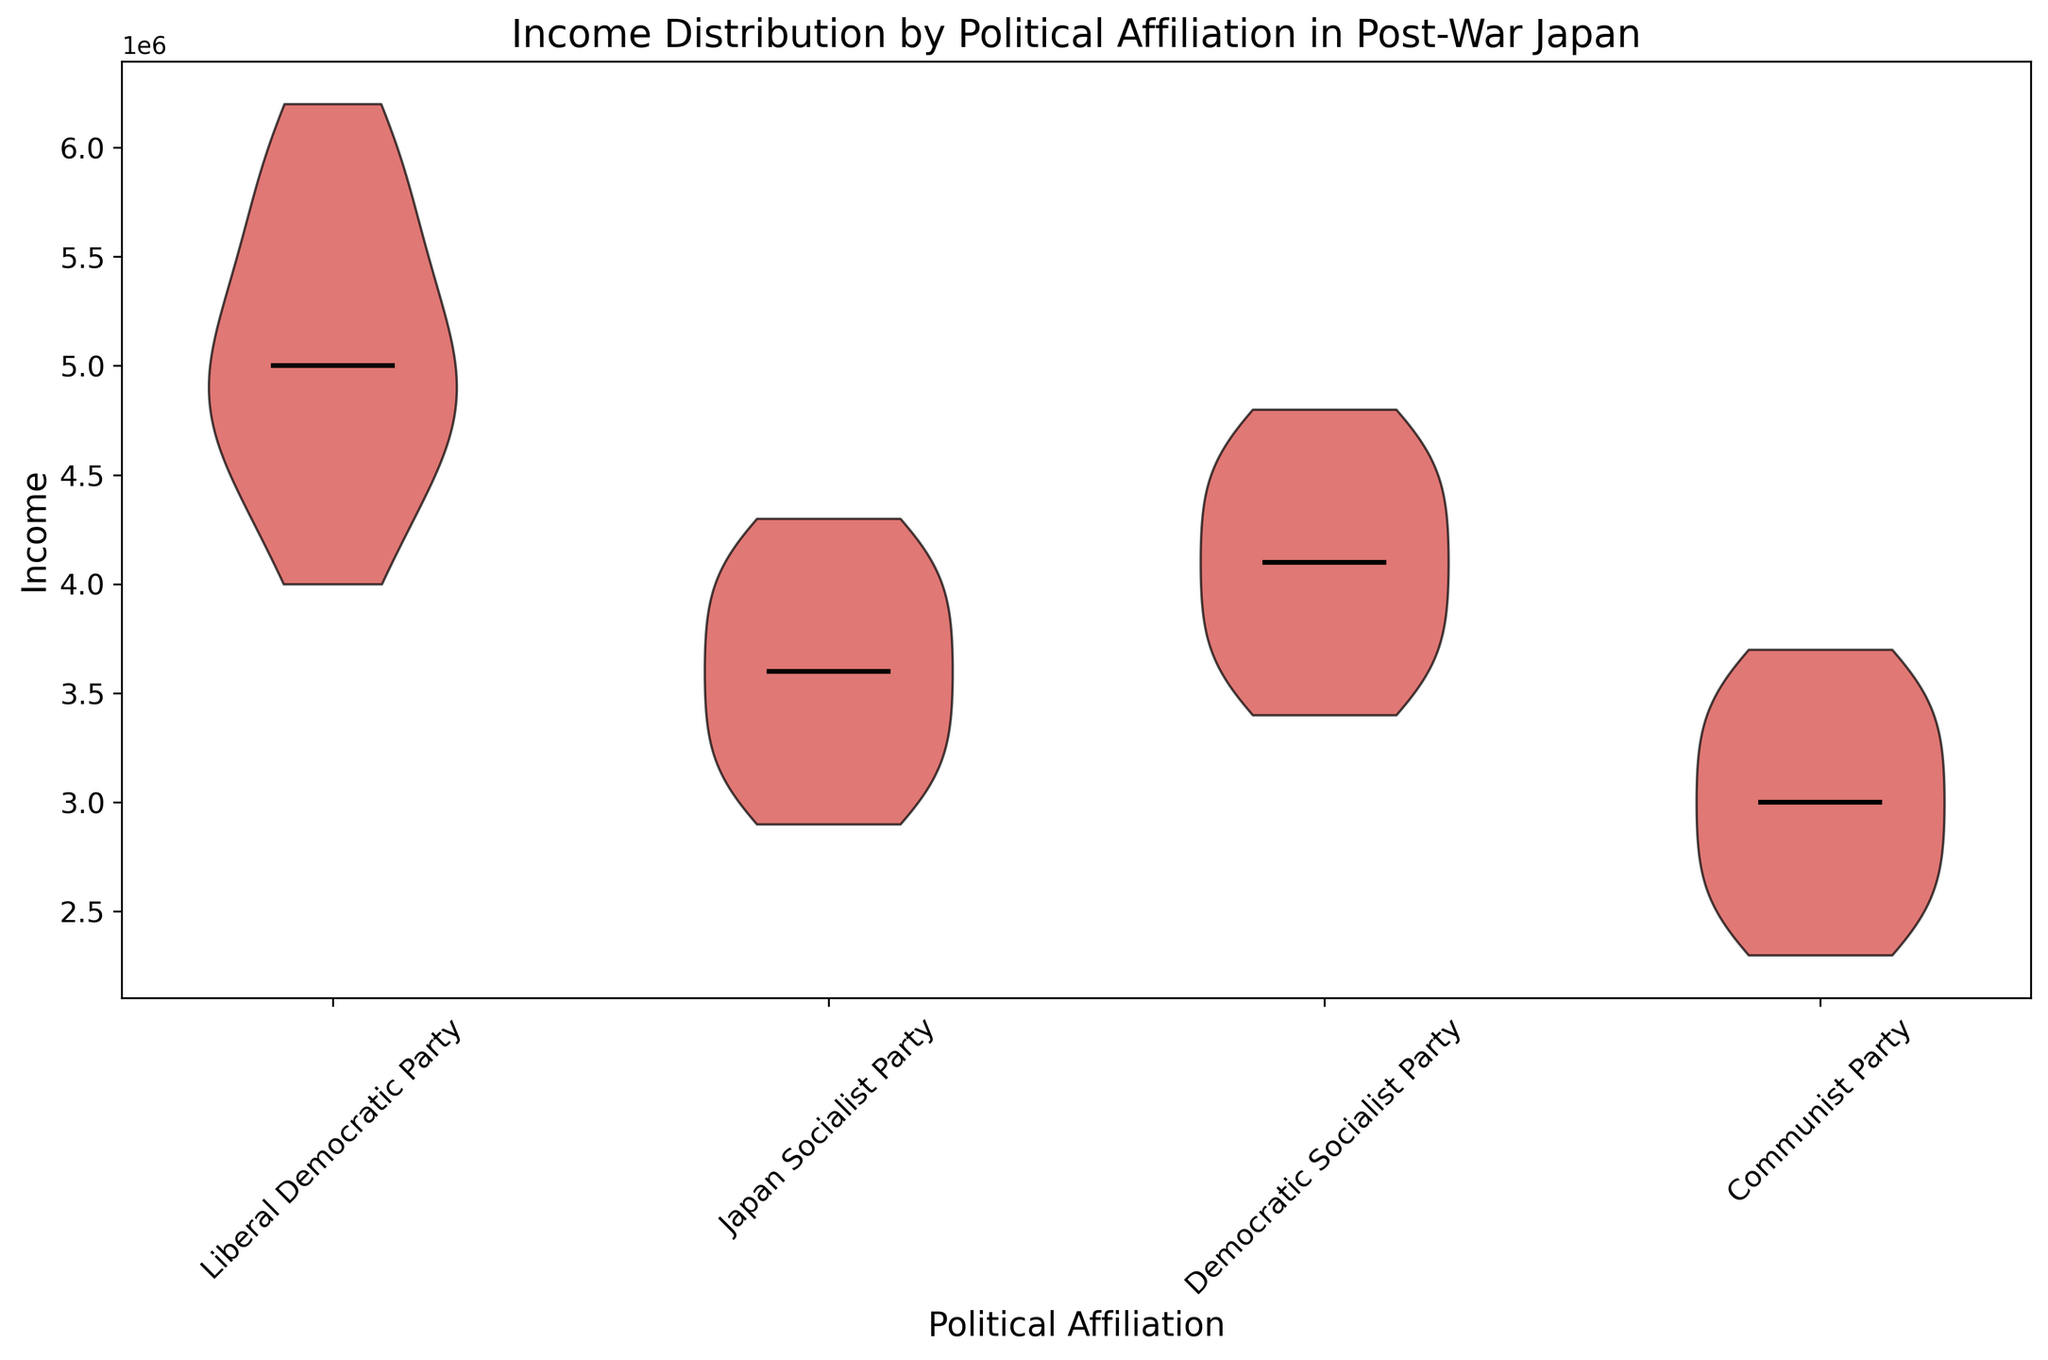What is the median income for each political affiliation? Look at the horizontal lines within each violin shape, which represent the median incomes for each political affiliation. The corresponding y-values of these lines indicate the median income.
Answer: Liberal Democratic Party: 5300000, Japan Socialist Party: 3600000, Democratic Socialist Party: 4200000, Communist Party: 2900000 Which political affiliation has the highest median income? Compare the median incomes represented by the horizontal lines within each violin plot to determine which one is the highest.
Answer: Liberal Democratic Party Is the median income of the Japan Socialist Party greater than that of the Communist Party? Compare the horizontal lines representing the median incomes for the Japan Socialist Party and the Communist Party to see which one is higher.
Answer: Yes How do the income distributions of the Liberal Democratic Party and the Japan Socialist Party differ visually? Observe the shapes and spreads of the violin plots for both parties. The Liberal Democratic Party's distribution is wider and shifted towards higher income values, while the Japan Socialist Party's distribution is more concentrated towards the center.
Answer: Liberal Democratic Party's distribution is wider and higher; Japan Socialist Party's distribution is more concentrated and lower What can be inferred about the spread of income values within the Democratic Socialist Party compared to the Communist Party? Look at the width of the violin plots. A wider plot indicates a larger spread in income values, and vice versa.
Answer: Democratic Socialist Party has a larger spread in income values compared to the Communist Party Between the Japan Socialist Party and the Democratic Socialist Party, which has a wider range of income values? Compare the width and spread of the violin plots of the two parties. The Democratic Socialist Party's plot is wider and extends further, indicating a wider range of income values.
Answer: Democratic Socialist Party Which political affiliation has the most varied distribution of income values? Look at the width and shape of the violin plots. The wider and more spread out the plot, the more varied the distribution.
Answer: Liberal Democratic Party What is the color used to represent all the income distributions in the violin plot? Observe the color of the violin plots used to represent the income distributions. All plots use the same color.
Answer: Red Does the Communist Party have any high extreme income values compared to other political affiliations? Compare the upper bounds of the violin plots for all political affiliations to see if the Communist Party has any high extreme income values.
Answer: No Is there a political affiliation where the median income surpasses 6,000,000 yen? Examine the horizontal medians of each political affiliation to see if any surpass the 6,000,000 yen mark.
Answer: No 